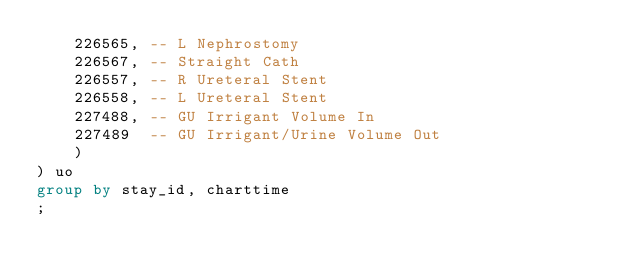Convert code to text. <code><loc_0><loc_0><loc_500><loc_500><_SQL_>    226565, -- L Nephrostomy
    226567, -- Straight Cath
    226557, -- R Ureteral Stent
    226558, -- L Ureteral Stent
    227488, -- GU Irrigant Volume In
    227489  -- GU Irrigant/Urine Volume Out
    )
) uo
group by stay_id, charttime
;
</code> 